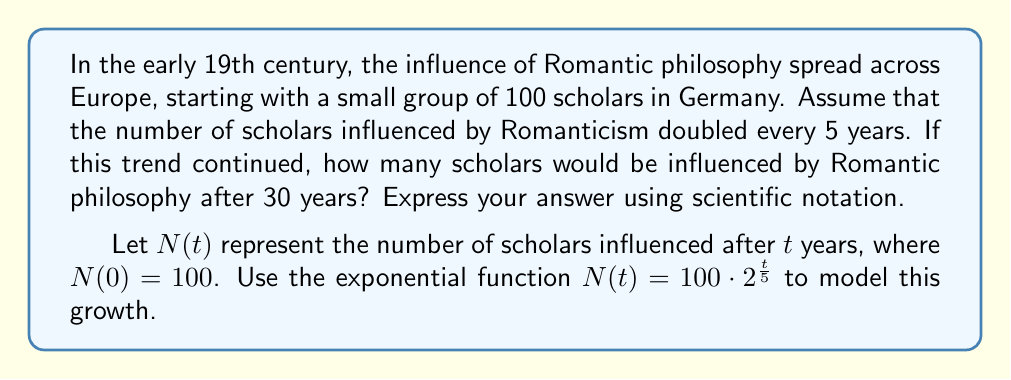Teach me how to tackle this problem. To solve this problem, we'll use the given exponential function:

$N(t) = 100 \cdot 2^{\frac{t}{5}}$

Where:
- $N(t)$ is the number of scholars influenced after $t$ years
- 100 is the initial number of scholars
- 2 is the growth factor (doubling every 5 years)
- $\frac{t}{5}$ represents the number of 5-year periods that have passed

We want to find $N(30)$, so we'll substitute $t = 30$ into the equation:

$N(30) = 100 \cdot 2^{\frac{30}{5}}$

Simplify the exponent:
$N(30) = 100 \cdot 2^6$

Calculate $2^6$:
$N(30) = 100 \cdot 64$

Multiply:
$N(30) = 6400$

To express this in scientific notation, we move the decimal point 3 places to the left:

$N(30) = 6.4 \times 10^3$
Answer: $6.4 \times 10^3$ scholars 